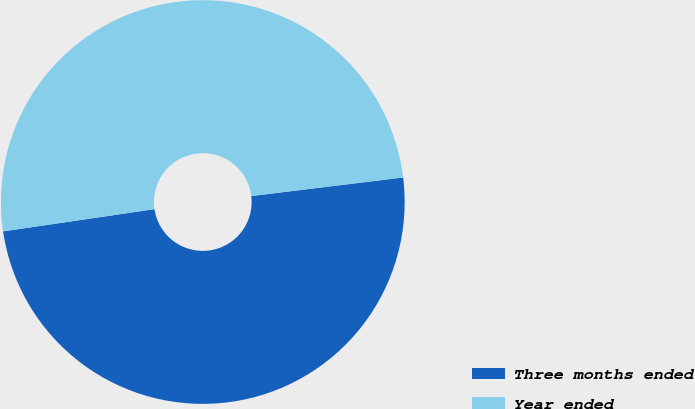<chart> <loc_0><loc_0><loc_500><loc_500><pie_chart><fcel>Three months ended<fcel>Year ended<nl><fcel>49.62%<fcel>50.38%<nl></chart> 